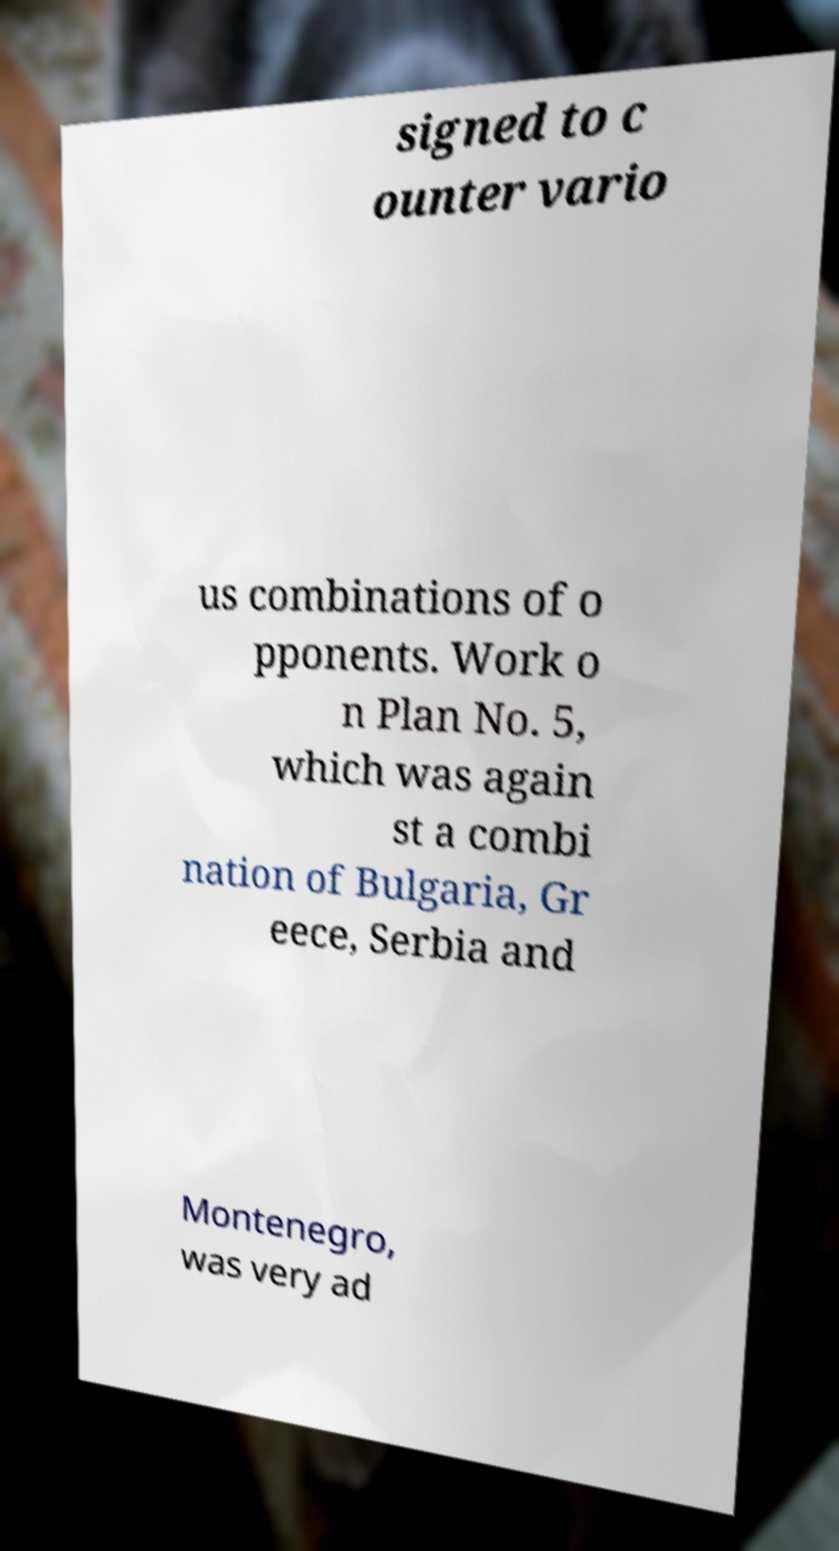Please read and relay the text visible in this image. What does it say? signed to c ounter vario us combinations of o pponents. Work o n Plan No. 5, which was again st a combi nation of Bulgaria, Gr eece, Serbia and Montenegro, was very ad 